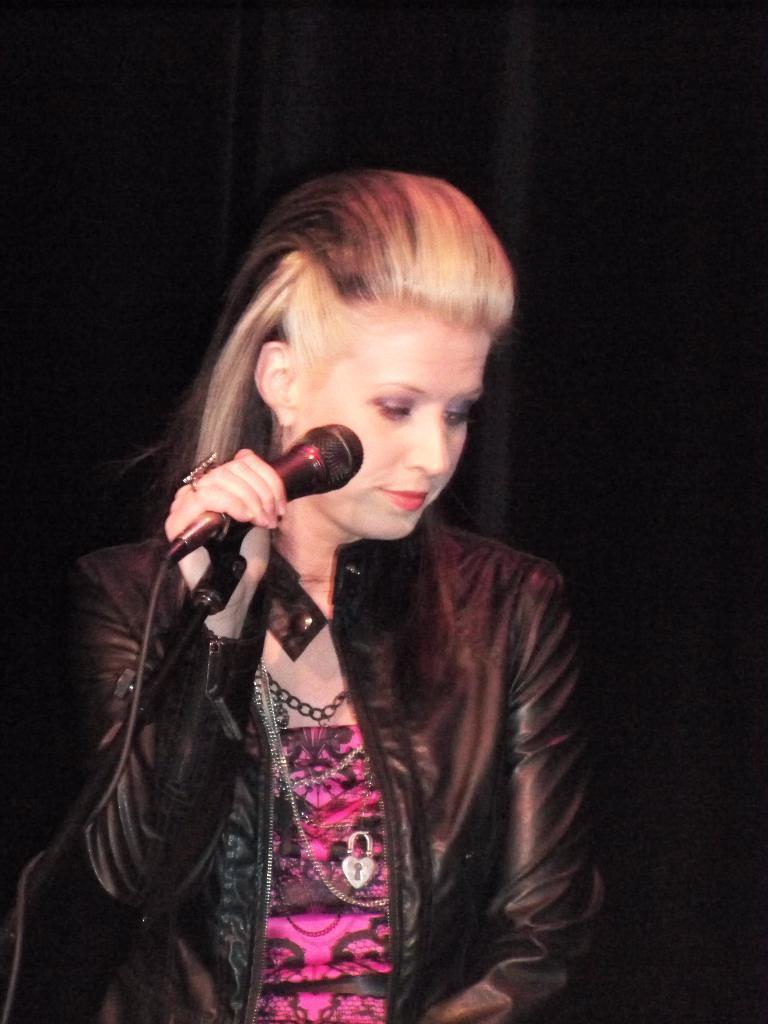Could you give a brief overview of what you see in this image? This woman wore jacket, chains and holding mic and looking downwards. 